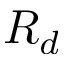<formula> <loc_0><loc_0><loc_500><loc_500>R _ { d }</formula> 